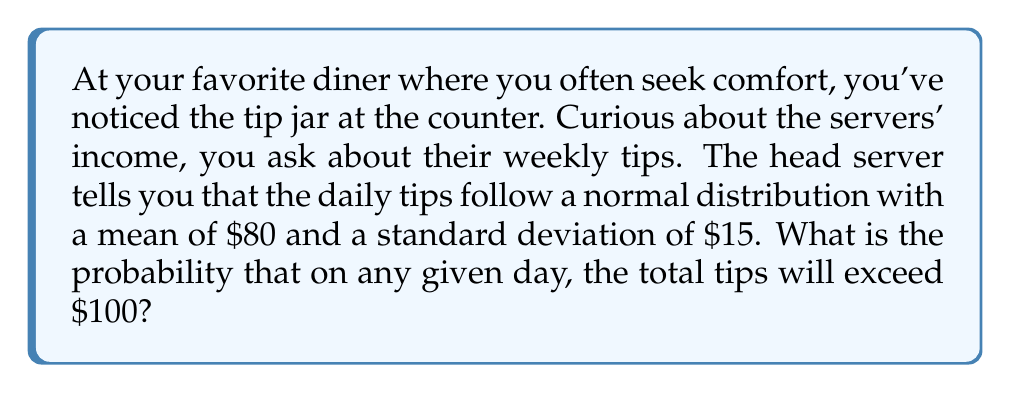Show me your answer to this math problem. Let's approach this step-by-step:

1) Let X be the random variable representing the daily tips. We're told that X follows a normal distribution with:
   
   $\mu = 80$ (mean)
   $\sigma = 15$ (standard deviation)

2) We want to find P(X > 100), the probability that X exceeds 100.

3) For a normal distribution, we typically use the standard normal distribution (Z-score) to calculate probabilities. The Z-score formula is:

   $$Z = \frac{X - \mu}{\sigma}$$

4) Let's calculate the Z-score for X = 100:

   $$Z = \frac{100 - 80}{15} = \frac{20}{15} \approx 1.33$$

5) Now, we need to find P(Z > 1.33). This is equivalent to 1 - P(Z < 1.33).

6) Using a standard normal distribution table or calculator, we can find that:
   
   P(Z < 1.33) ≈ 0.9082

7) Therefore:
   
   P(Z > 1.33) = 1 - P(Z < 1.33) = 1 - 0.9082 = 0.0918

8) This means there's approximately a 0.0918 or 9.18% chance that the daily tips will exceed $100.
Answer: The probability that the daily tips will exceed $100 is approximately 0.0918 or 9.18%. 